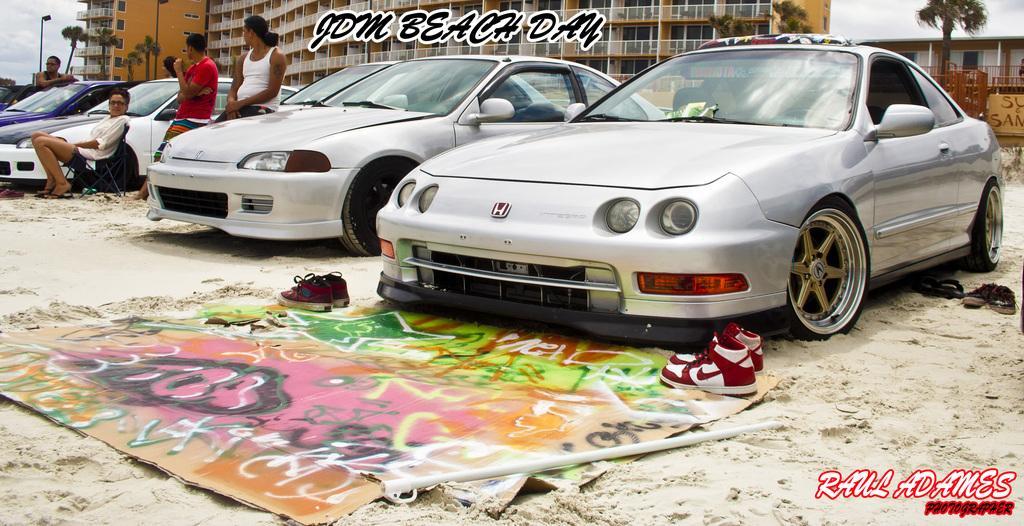Could you give a brief overview of what you see in this image? In this image there are so many cars parked and there are a few people standing and sitting on the chair, there are two pairs of shoes and a banner on the surface. In the background there are buildings, trees and the sky. In the foreground of the image there is some text. 